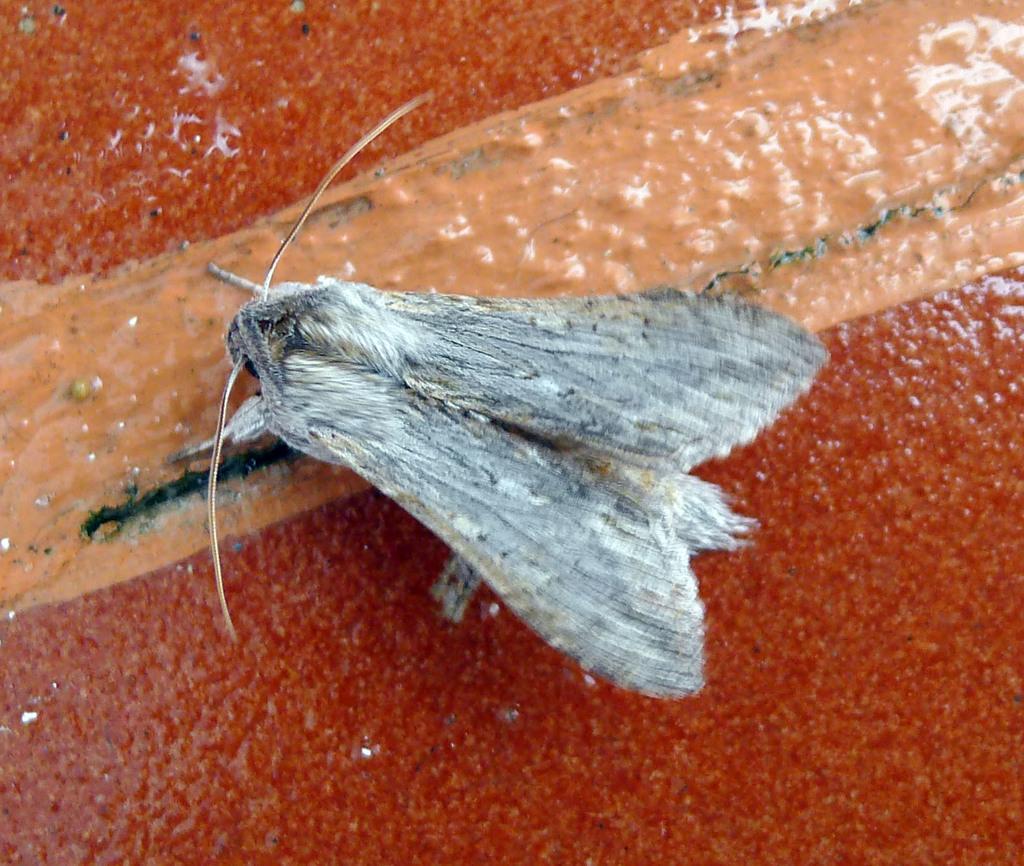How would you summarize this image in a sentence or two? Here there is an insect, that is red color. 